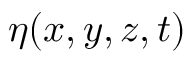<formula> <loc_0><loc_0><loc_500><loc_500>\eta ( x , y , z , t )</formula> 